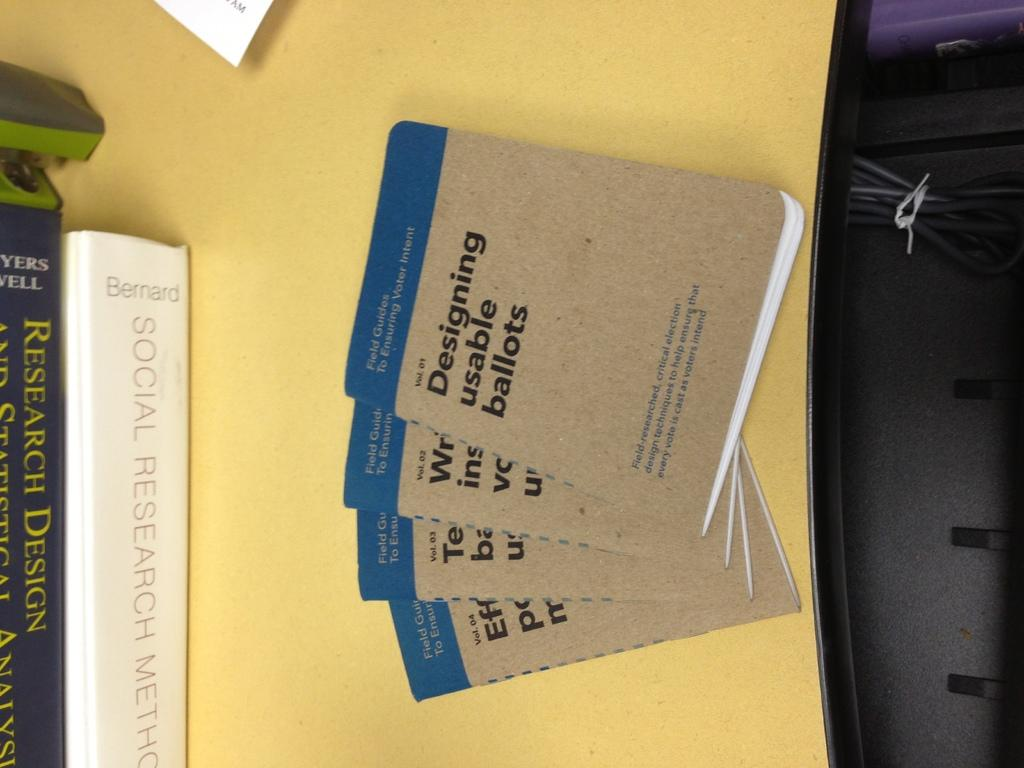Provide a one-sentence caption for the provided image. A stack of books titled Designing usable ballots are laying on a yellow table. 